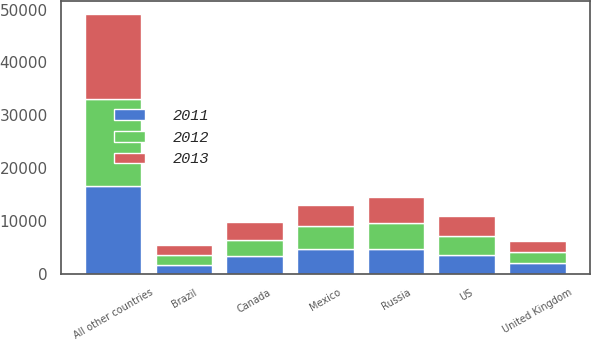<chart> <loc_0><loc_0><loc_500><loc_500><stacked_bar_chart><ecel><fcel>US<fcel>Russia<fcel>Mexico<fcel>Canada<fcel>United Kingdom<fcel>Brazil<fcel>All other countries<nl><fcel>2012<fcel>3659.5<fcel>4908<fcel>4347<fcel>3195<fcel>2115<fcel>1835<fcel>16389<nl><fcel>2013<fcel>3659.5<fcel>4861<fcel>3955<fcel>3290<fcel>2102<fcel>1866<fcel>16070<nl><fcel>2011<fcel>3659.5<fcel>4749<fcel>4782<fcel>3364<fcel>2075<fcel>1838<fcel>16643<nl></chart> 